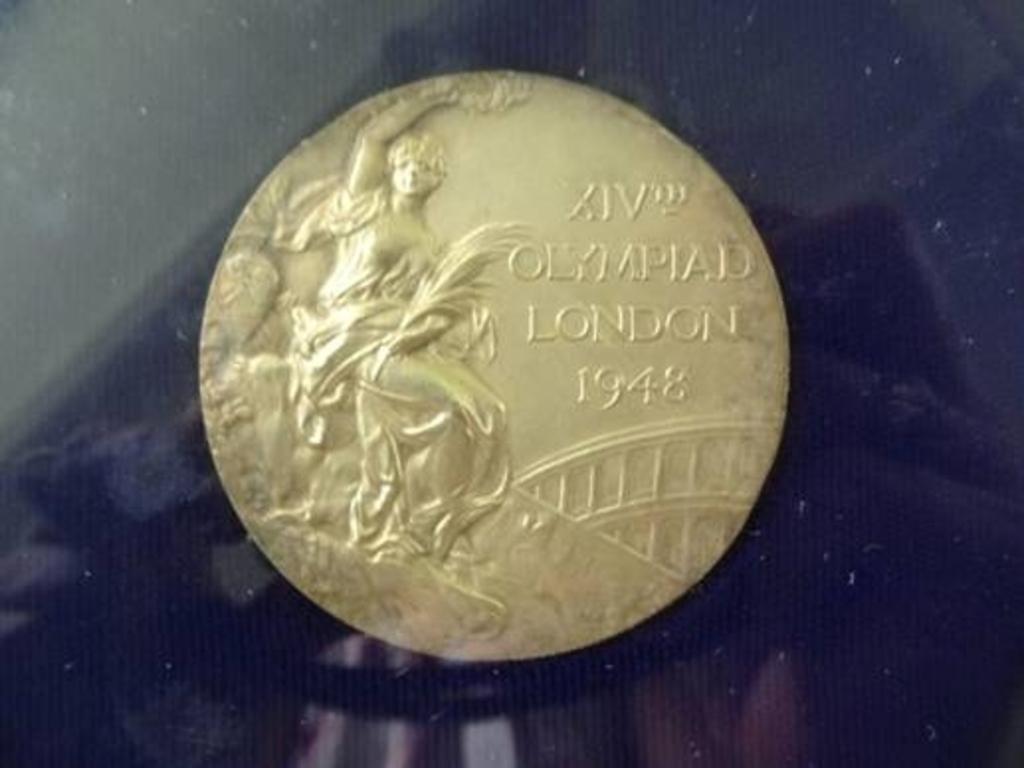What year is this coin?
Your answer should be very brief. 1948. What city is mentioned on the coin?
Your answer should be compact. London. 